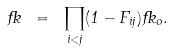Convert formula to latex. <formula><loc_0><loc_0><loc_500><loc_500>\Psi \ = \ \prod _ { i < j } ( 1 - F _ { i j } ) \Psi _ { o } .</formula> 